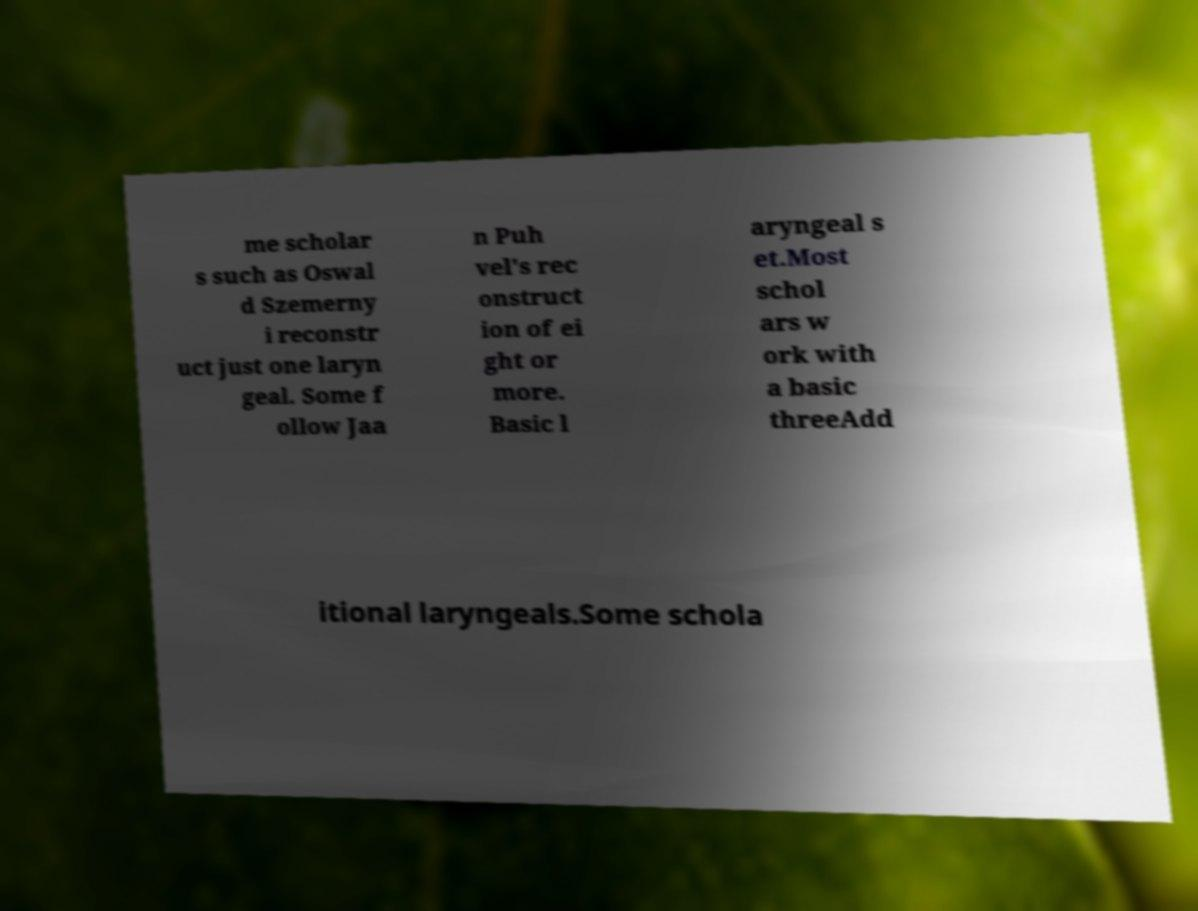Could you extract and type out the text from this image? me scholar s such as Oswal d Szemerny i reconstr uct just one laryn geal. Some f ollow Jaa n Puh vel's rec onstruct ion of ei ght or more. Basic l aryngeal s et.Most schol ars w ork with a basic threeAdd itional laryngeals.Some schola 